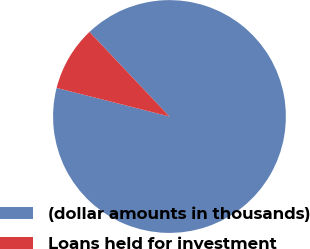<chart> <loc_0><loc_0><loc_500><loc_500><pie_chart><fcel>(dollar amounts in thousands)<fcel>Loans held for investment<nl><fcel>91.01%<fcel>8.99%<nl></chart> 